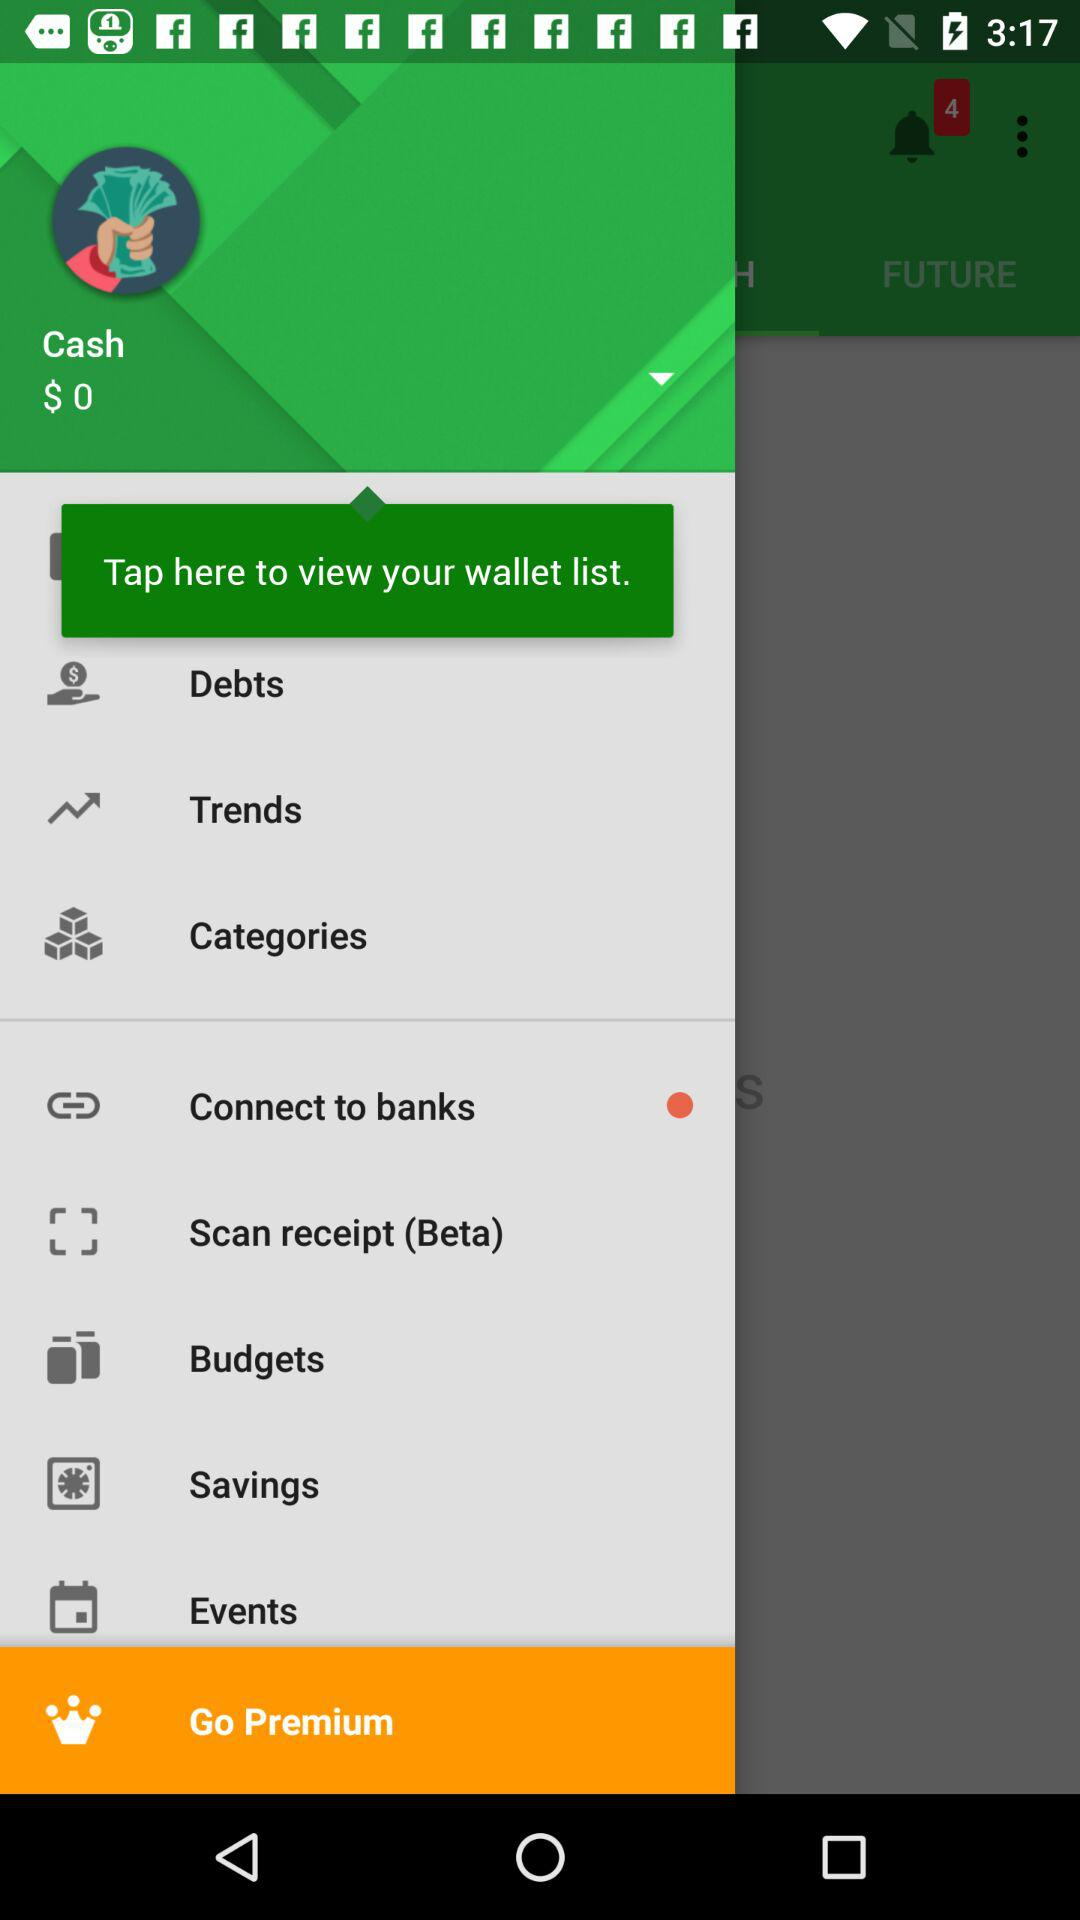What is the balance? The balance is $ 0. 